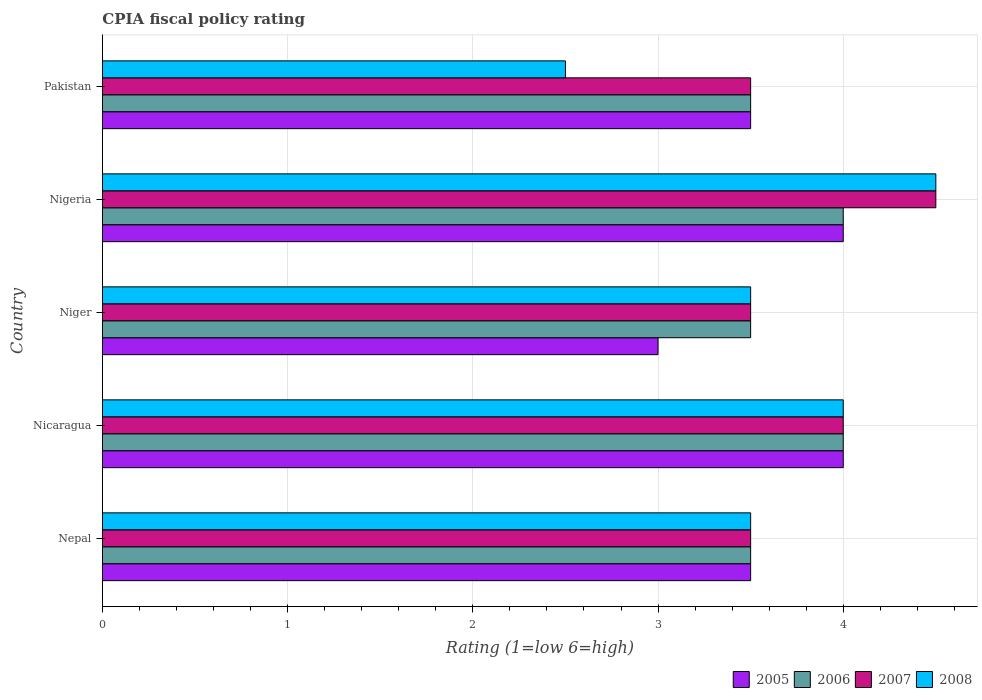How many bars are there on the 4th tick from the top?
Offer a terse response. 4. How many bars are there on the 1st tick from the bottom?
Keep it short and to the point. 4. What is the label of the 4th group of bars from the top?
Provide a short and direct response. Nicaragua. In how many cases, is the number of bars for a given country not equal to the number of legend labels?
Keep it short and to the point. 0. What is the CPIA rating in 2006 in Nepal?
Provide a short and direct response. 3.5. Across all countries, what is the minimum CPIA rating in 2005?
Keep it short and to the point. 3. In which country was the CPIA rating in 2006 maximum?
Give a very brief answer. Nicaragua. In which country was the CPIA rating in 2005 minimum?
Your answer should be compact. Niger. What is the total CPIA rating in 2005 in the graph?
Offer a very short reply. 18. What is the difference between the CPIA rating in 2006 in Nepal and that in Niger?
Ensure brevity in your answer.  0. What is the difference between the CPIA rating in 2008 in Nicaragua and the CPIA rating in 2007 in Nepal?
Your answer should be very brief. 0.5. What is the average CPIA rating in 2006 per country?
Give a very brief answer. 3.7. What is the difference between the CPIA rating in 2005 and CPIA rating in 2006 in Pakistan?
Ensure brevity in your answer.  0. Is the CPIA rating in 2006 in Niger less than that in Nigeria?
Your answer should be very brief. Yes. Is the sum of the CPIA rating in 2007 in Nicaragua and Nigeria greater than the maximum CPIA rating in 2008 across all countries?
Your answer should be compact. Yes. What does the 3rd bar from the bottom in Niger represents?
Keep it short and to the point. 2007. Is it the case that in every country, the sum of the CPIA rating in 2007 and CPIA rating in 2005 is greater than the CPIA rating in 2008?
Your answer should be very brief. Yes. Are all the bars in the graph horizontal?
Keep it short and to the point. Yes. How many countries are there in the graph?
Give a very brief answer. 5. Where does the legend appear in the graph?
Your response must be concise. Bottom right. How are the legend labels stacked?
Give a very brief answer. Horizontal. What is the title of the graph?
Provide a short and direct response. CPIA fiscal policy rating. What is the Rating (1=low 6=high) of 2006 in Nepal?
Provide a short and direct response. 3.5. What is the Rating (1=low 6=high) in 2006 in Nicaragua?
Your response must be concise. 4. What is the Rating (1=low 6=high) of 2007 in Nicaragua?
Offer a terse response. 4. What is the Rating (1=low 6=high) in 2008 in Nicaragua?
Provide a succinct answer. 4. What is the Rating (1=low 6=high) of 2005 in Niger?
Make the answer very short. 3. What is the Rating (1=low 6=high) in 2006 in Niger?
Keep it short and to the point. 3.5. What is the Rating (1=low 6=high) of 2008 in Niger?
Your response must be concise. 3.5. What is the Rating (1=low 6=high) of 2005 in Nigeria?
Give a very brief answer. 4. What is the Rating (1=low 6=high) in 2006 in Nigeria?
Your response must be concise. 4. What is the Rating (1=low 6=high) in 2008 in Nigeria?
Your answer should be very brief. 4.5. What is the Rating (1=low 6=high) in 2007 in Pakistan?
Your answer should be very brief. 3.5. Across all countries, what is the minimum Rating (1=low 6=high) in 2006?
Ensure brevity in your answer.  3.5. Across all countries, what is the minimum Rating (1=low 6=high) in 2008?
Keep it short and to the point. 2.5. What is the total Rating (1=low 6=high) in 2007 in the graph?
Ensure brevity in your answer.  19. What is the difference between the Rating (1=low 6=high) in 2006 in Nepal and that in Nicaragua?
Ensure brevity in your answer.  -0.5. What is the difference between the Rating (1=low 6=high) in 2007 in Nepal and that in Niger?
Your answer should be very brief. 0. What is the difference between the Rating (1=low 6=high) in 2005 in Nepal and that in Nigeria?
Provide a short and direct response. -0.5. What is the difference between the Rating (1=low 6=high) of 2006 in Nepal and that in Nigeria?
Give a very brief answer. -0.5. What is the difference between the Rating (1=low 6=high) in 2008 in Nepal and that in Nigeria?
Your answer should be compact. -1. What is the difference between the Rating (1=low 6=high) in 2005 in Nepal and that in Pakistan?
Make the answer very short. 0. What is the difference between the Rating (1=low 6=high) of 2007 in Nepal and that in Pakistan?
Offer a terse response. 0. What is the difference between the Rating (1=low 6=high) in 2008 in Nepal and that in Pakistan?
Keep it short and to the point. 1. What is the difference between the Rating (1=low 6=high) of 2005 in Nicaragua and that in Niger?
Offer a terse response. 1. What is the difference between the Rating (1=low 6=high) of 2006 in Nicaragua and that in Niger?
Give a very brief answer. 0.5. What is the difference between the Rating (1=low 6=high) of 2007 in Nicaragua and that in Niger?
Offer a terse response. 0.5. What is the difference between the Rating (1=low 6=high) in 2006 in Nicaragua and that in Nigeria?
Keep it short and to the point. 0. What is the difference between the Rating (1=low 6=high) of 2007 in Nicaragua and that in Nigeria?
Provide a succinct answer. -0.5. What is the difference between the Rating (1=low 6=high) in 2008 in Nicaragua and that in Nigeria?
Your response must be concise. -0.5. What is the difference between the Rating (1=low 6=high) of 2008 in Nicaragua and that in Pakistan?
Keep it short and to the point. 1.5. What is the difference between the Rating (1=low 6=high) of 2006 in Niger and that in Nigeria?
Give a very brief answer. -0.5. What is the difference between the Rating (1=low 6=high) in 2007 in Niger and that in Nigeria?
Provide a short and direct response. -1. What is the difference between the Rating (1=low 6=high) in 2005 in Niger and that in Pakistan?
Your answer should be compact. -0.5. What is the difference between the Rating (1=low 6=high) in 2006 in Niger and that in Pakistan?
Provide a short and direct response. 0. What is the difference between the Rating (1=low 6=high) of 2007 in Niger and that in Pakistan?
Offer a terse response. 0. What is the difference between the Rating (1=low 6=high) in 2005 in Nigeria and that in Pakistan?
Keep it short and to the point. 0.5. What is the difference between the Rating (1=low 6=high) in 2008 in Nigeria and that in Pakistan?
Keep it short and to the point. 2. What is the difference between the Rating (1=low 6=high) of 2005 in Nepal and the Rating (1=low 6=high) of 2007 in Nicaragua?
Give a very brief answer. -0.5. What is the difference between the Rating (1=low 6=high) of 2005 in Nepal and the Rating (1=low 6=high) of 2008 in Nicaragua?
Provide a succinct answer. -0.5. What is the difference between the Rating (1=low 6=high) of 2006 in Nepal and the Rating (1=low 6=high) of 2007 in Nicaragua?
Offer a terse response. -0.5. What is the difference between the Rating (1=low 6=high) in 2006 in Nepal and the Rating (1=low 6=high) in 2008 in Nicaragua?
Your answer should be very brief. -0.5. What is the difference between the Rating (1=low 6=high) in 2007 in Nepal and the Rating (1=low 6=high) in 2008 in Nicaragua?
Your answer should be compact. -0.5. What is the difference between the Rating (1=low 6=high) of 2005 in Nepal and the Rating (1=low 6=high) of 2006 in Niger?
Offer a very short reply. 0. What is the difference between the Rating (1=low 6=high) of 2005 in Nepal and the Rating (1=low 6=high) of 2007 in Niger?
Offer a terse response. 0. What is the difference between the Rating (1=low 6=high) in 2005 in Nepal and the Rating (1=low 6=high) in 2008 in Niger?
Offer a very short reply. 0. What is the difference between the Rating (1=low 6=high) in 2006 in Nepal and the Rating (1=low 6=high) in 2008 in Niger?
Keep it short and to the point. 0. What is the difference between the Rating (1=low 6=high) of 2007 in Nepal and the Rating (1=low 6=high) of 2008 in Niger?
Your answer should be very brief. 0. What is the difference between the Rating (1=low 6=high) in 2005 in Nepal and the Rating (1=low 6=high) in 2006 in Nigeria?
Your response must be concise. -0.5. What is the difference between the Rating (1=low 6=high) in 2005 in Nepal and the Rating (1=low 6=high) in 2008 in Nigeria?
Provide a short and direct response. -1. What is the difference between the Rating (1=low 6=high) of 2005 in Nepal and the Rating (1=low 6=high) of 2007 in Pakistan?
Make the answer very short. 0. What is the difference between the Rating (1=low 6=high) in 2005 in Nepal and the Rating (1=low 6=high) in 2008 in Pakistan?
Give a very brief answer. 1. What is the difference between the Rating (1=low 6=high) of 2006 in Nepal and the Rating (1=low 6=high) of 2008 in Pakistan?
Provide a succinct answer. 1. What is the difference between the Rating (1=low 6=high) of 2007 in Nepal and the Rating (1=low 6=high) of 2008 in Pakistan?
Provide a short and direct response. 1. What is the difference between the Rating (1=low 6=high) of 2005 in Nicaragua and the Rating (1=low 6=high) of 2006 in Niger?
Your response must be concise. 0.5. What is the difference between the Rating (1=low 6=high) in 2005 in Nicaragua and the Rating (1=low 6=high) in 2008 in Nigeria?
Make the answer very short. -0.5. What is the difference between the Rating (1=low 6=high) in 2006 in Nicaragua and the Rating (1=low 6=high) in 2008 in Nigeria?
Your answer should be compact. -0.5. What is the difference between the Rating (1=low 6=high) of 2007 in Nicaragua and the Rating (1=low 6=high) of 2008 in Nigeria?
Provide a succinct answer. -0.5. What is the difference between the Rating (1=low 6=high) in 2005 in Nicaragua and the Rating (1=low 6=high) in 2006 in Pakistan?
Provide a succinct answer. 0.5. What is the difference between the Rating (1=low 6=high) in 2005 in Nicaragua and the Rating (1=low 6=high) in 2007 in Pakistan?
Give a very brief answer. 0.5. What is the difference between the Rating (1=low 6=high) of 2006 in Nicaragua and the Rating (1=low 6=high) of 2008 in Pakistan?
Offer a very short reply. 1.5. What is the difference between the Rating (1=low 6=high) of 2005 in Niger and the Rating (1=low 6=high) of 2006 in Nigeria?
Ensure brevity in your answer.  -1. What is the difference between the Rating (1=low 6=high) of 2005 in Niger and the Rating (1=low 6=high) of 2007 in Nigeria?
Offer a terse response. -1.5. What is the difference between the Rating (1=low 6=high) in 2005 in Niger and the Rating (1=low 6=high) in 2008 in Nigeria?
Provide a short and direct response. -1.5. What is the difference between the Rating (1=low 6=high) in 2007 in Niger and the Rating (1=low 6=high) in 2008 in Nigeria?
Give a very brief answer. -1. What is the difference between the Rating (1=low 6=high) in 2005 in Niger and the Rating (1=low 6=high) in 2006 in Pakistan?
Offer a very short reply. -0.5. What is the difference between the Rating (1=low 6=high) of 2006 in Niger and the Rating (1=low 6=high) of 2008 in Pakistan?
Offer a very short reply. 1. What is the difference between the Rating (1=low 6=high) in 2005 in Nigeria and the Rating (1=low 6=high) in 2008 in Pakistan?
Provide a succinct answer. 1.5. What is the difference between the Rating (1=low 6=high) of 2006 in Nigeria and the Rating (1=low 6=high) of 2007 in Pakistan?
Provide a succinct answer. 0.5. What is the difference between the Rating (1=low 6=high) in 2007 in Nigeria and the Rating (1=low 6=high) in 2008 in Pakistan?
Offer a terse response. 2. What is the average Rating (1=low 6=high) in 2005 per country?
Offer a terse response. 3.6. What is the average Rating (1=low 6=high) of 2006 per country?
Your answer should be very brief. 3.7. What is the average Rating (1=low 6=high) of 2008 per country?
Your response must be concise. 3.6. What is the difference between the Rating (1=low 6=high) of 2005 and Rating (1=low 6=high) of 2008 in Nepal?
Keep it short and to the point. 0. What is the difference between the Rating (1=low 6=high) of 2006 and Rating (1=low 6=high) of 2007 in Nepal?
Keep it short and to the point. 0. What is the difference between the Rating (1=low 6=high) in 2006 and Rating (1=low 6=high) in 2008 in Nepal?
Your answer should be very brief. 0. What is the difference between the Rating (1=low 6=high) in 2007 and Rating (1=low 6=high) in 2008 in Nepal?
Keep it short and to the point. 0. What is the difference between the Rating (1=low 6=high) in 2005 and Rating (1=low 6=high) in 2006 in Nicaragua?
Your answer should be compact. 0. What is the difference between the Rating (1=low 6=high) in 2005 and Rating (1=low 6=high) in 2007 in Nicaragua?
Ensure brevity in your answer.  0. What is the difference between the Rating (1=low 6=high) of 2006 and Rating (1=low 6=high) of 2007 in Nicaragua?
Keep it short and to the point. 0. What is the difference between the Rating (1=low 6=high) in 2006 and Rating (1=low 6=high) in 2007 in Niger?
Your answer should be compact. 0. What is the difference between the Rating (1=low 6=high) of 2005 and Rating (1=low 6=high) of 2006 in Nigeria?
Provide a succinct answer. 0. What is the difference between the Rating (1=low 6=high) in 2006 and Rating (1=low 6=high) in 2008 in Nigeria?
Offer a very short reply. -0.5. What is the difference between the Rating (1=low 6=high) of 2005 and Rating (1=low 6=high) of 2007 in Pakistan?
Your response must be concise. 0. What is the difference between the Rating (1=low 6=high) of 2006 and Rating (1=low 6=high) of 2007 in Pakistan?
Offer a very short reply. 0. What is the difference between the Rating (1=low 6=high) of 2006 and Rating (1=low 6=high) of 2008 in Pakistan?
Provide a short and direct response. 1. What is the ratio of the Rating (1=low 6=high) in 2007 in Nepal to that in Nicaragua?
Keep it short and to the point. 0.88. What is the ratio of the Rating (1=low 6=high) in 2006 in Nepal to that in Niger?
Offer a terse response. 1. What is the ratio of the Rating (1=low 6=high) in 2007 in Nepal to that in Niger?
Ensure brevity in your answer.  1. What is the ratio of the Rating (1=low 6=high) of 2008 in Nepal to that in Niger?
Make the answer very short. 1. What is the ratio of the Rating (1=low 6=high) of 2006 in Nepal to that in Nigeria?
Your response must be concise. 0.88. What is the ratio of the Rating (1=low 6=high) in 2005 in Nepal to that in Pakistan?
Keep it short and to the point. 1. What is the ratio of the Rating (1=low 6=high) of 2007 in Nicaragua to that in Niger?
Keep it short and to the point. 1.14. What is the ratio of the Rating (1=low 6=high) of 2008 in Nicaragua to that in Nigeria?
Your answer should be compact. 0.89. What is the ratio of the Rating (1=low 6=high) in 2005 in Nicaragua to that in Pakistan?
Provide a short and direct response. 1.14. What is the ratio of the Rating (1=low 6=high) of 2006 in Nicaragua to that in Pakistan?
Offer a very short reply. 1.14. What is the ratio of the Rating (1=low 6=high) in 2008 in Nicaragua to that in Pakistan?
Your answer should be very brief. 1.6. What is the ratio of the Rating (1=low 6=high) in 2006 in Niger to that in Nigeria?
Provide a short and direct response. 0.88. What is the ratio of the Rating (1=low 6=high) in 2007 in Niger to that in Nigeria?
Offer a very short reply. 0.78. What is the ratio of the Rating (1=low 6=high) of 2008 in Niger to that in Nigeria?
Your answer should be compact. 0.78. What is the ratio of the Rating (1=low 6=high) in 2005 in Niger to that in Pakistan?
Ensure brevity in your answer.  0.86. What is the ratio of the Rating (1=low 6=high) of 2006 in Niger to that in Pakistan?
Your answer should be compact. 1. What is the ratio of the Rating (1=low 6=high) in 2007 in Niger to that in Pakistan?
Make the answer very short. 1. What is the ratio of the Rating (1=low 6=high) of 2005 in Nigeria to that in Pakistan?
Offer a terse response. 1.14. What is the ratio of the Rating (1=low 6=high) in 2006 in Nigeria to that in Pakistan?
Give a very brief answer. 1.14. What is the ratio of the Rating (1=low 6=high) of 2008 in Nigeria to that in Pakistan?
Keep it short and to the point. 1.8. What is the difference between the highest and the second highest Rating (1=low 6=high) of 2005?
Keep it short and to the point. 0. What is the difference between the highest and the second highest Rating (1=low 6=high) in 2006?
Your answer should be very brief. 0. What is the difference between the highest and the lowest Rating (1=low 6=high) in 2007?
Give a very brief answer. 1. 